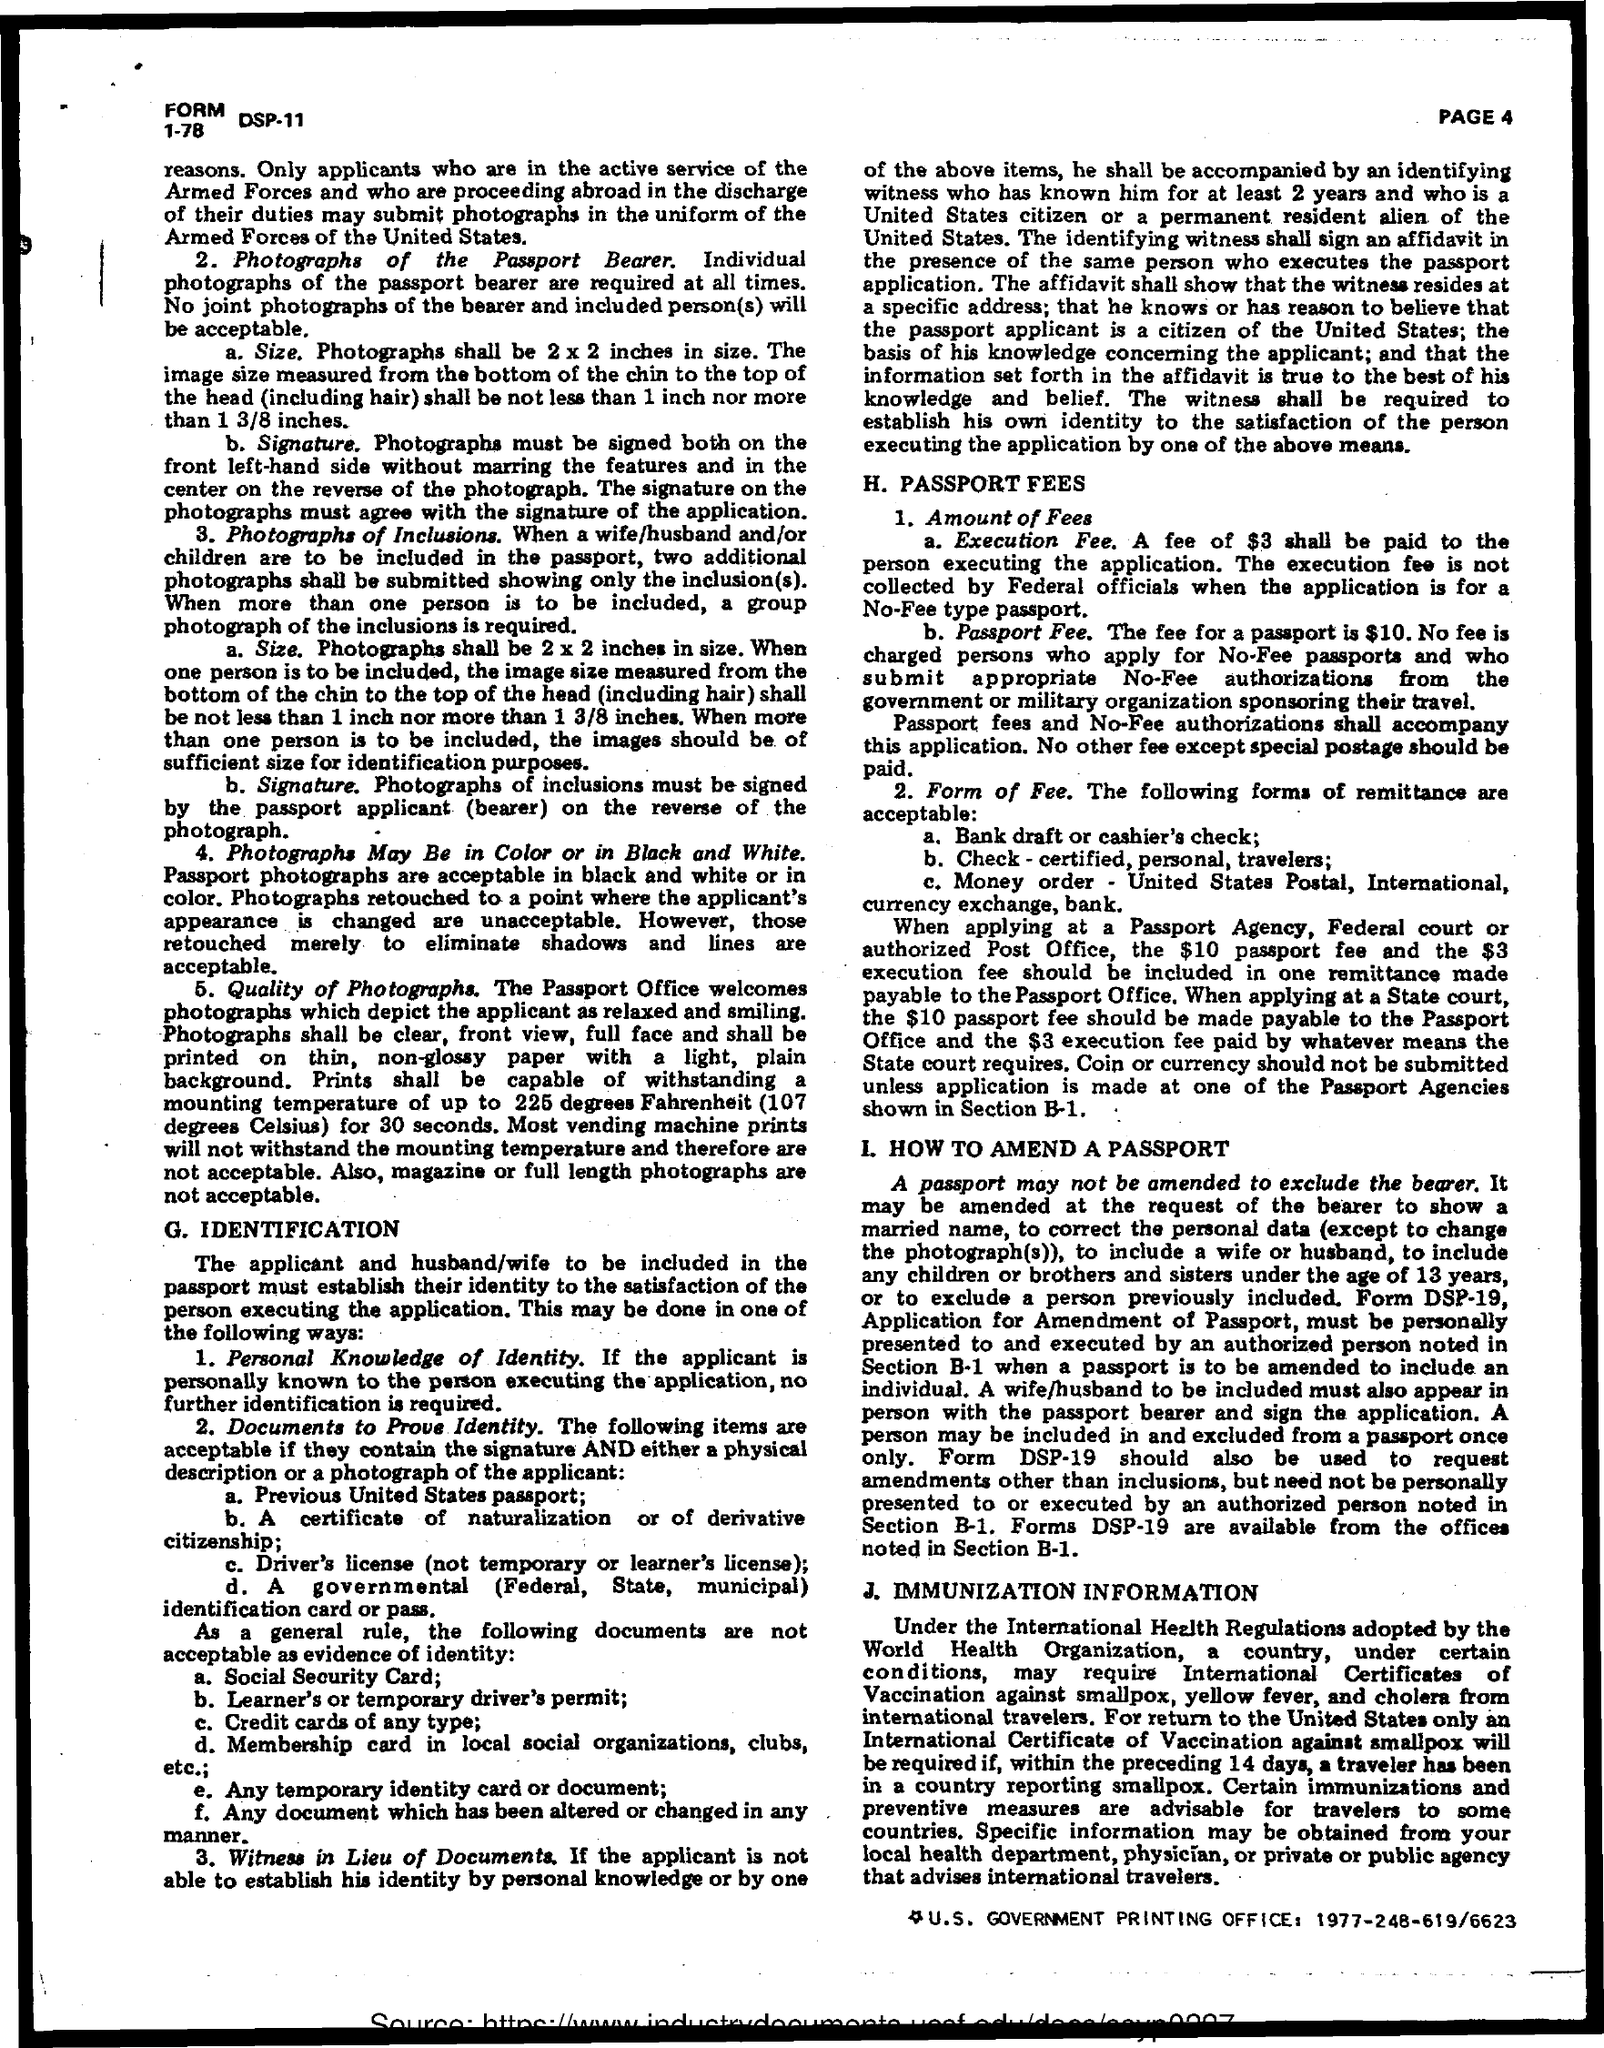Mention a couple of crucial points in this snapshot. What is an execution fee? It is $3... The passport fee is $10. 